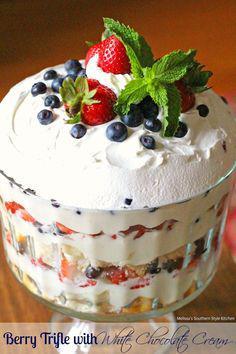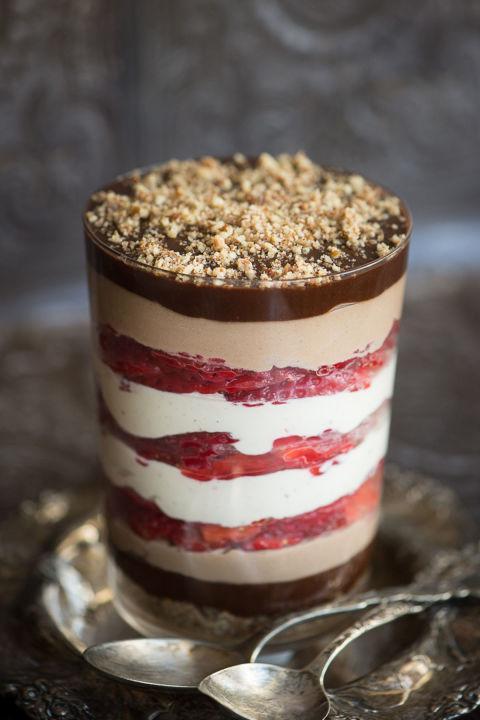The first image is the image on the left, the second image is the image on the right. Assess this claim about the two images: "A dessert in a footed glass has a neat row of berries around the rim for garnish.". Correct or not? Answer yes or no. No. The first image is the image on the left, the second image is the image on the right. Examine the images to the left and right. Is the description "One image shows a large layered dessert in a clear footed bowl, topped with a thick creamy layer and a garnish of the same items used in a lower layer." accurate? Answer yes or no. Yes. 